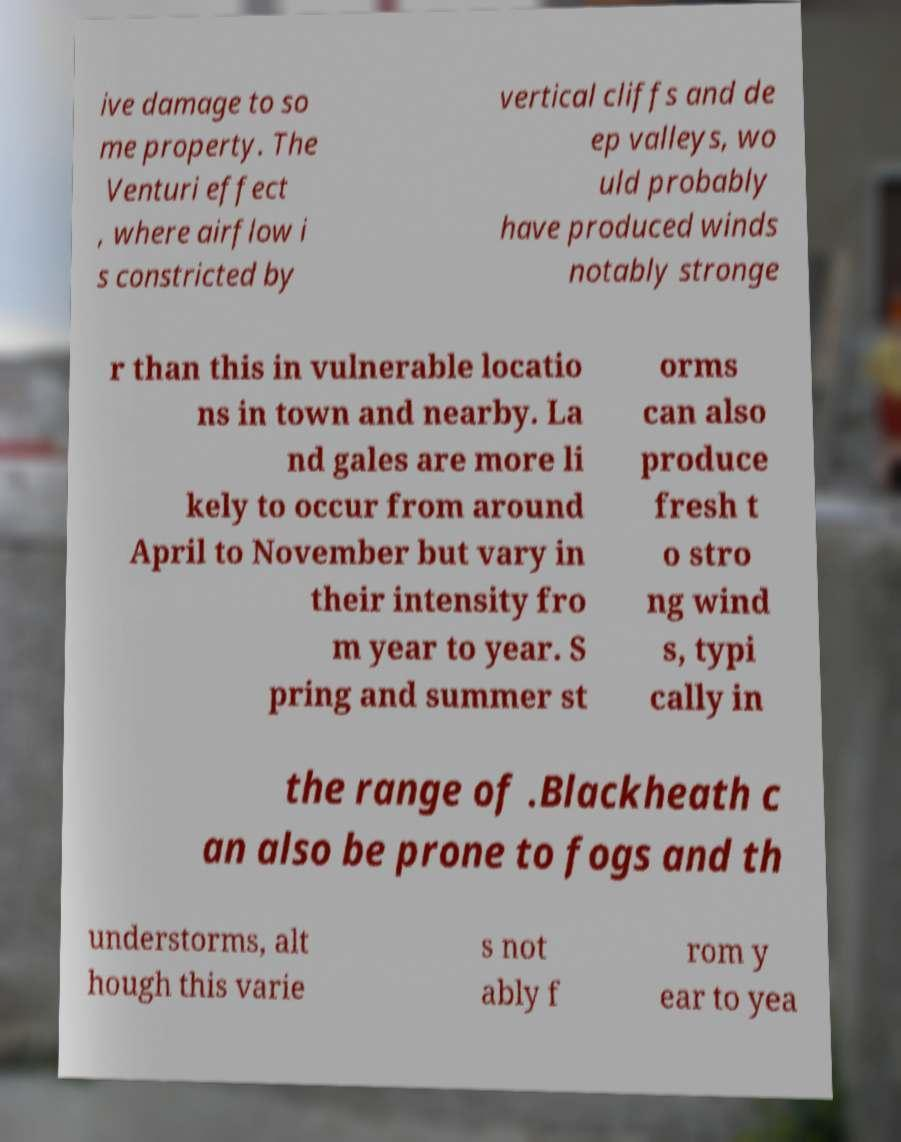Can you read and provide the text displayed in the image?This photo seems to have some interesting text. Can you extract and type it out for me? ive damage to so me property. The Venturi effect , where airflow i s constricted by vertical cliffs and de ep valleys, wo uld probably have produced winds notably stronge r than this in vulnerable locatio ns in town and nearby. La nd gales are more li kely to occur from around April to November but vary in their intensity fro m year to year. S pring and summer st orms can also produce fresh t o stro ng wind s, typi cally in the range of .Blackheath c an also be prone to fogs and th understorms, alt hough this varie s not ably f rom y ear to yea 